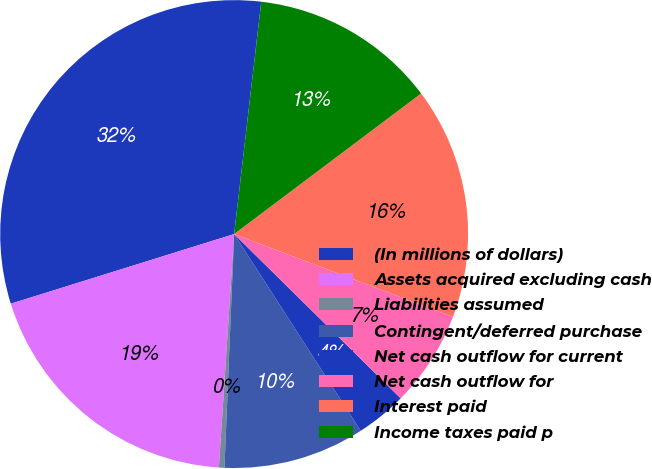<chart> <loc_0><loc_0><loc_500><loc_500><pie_chart><fcel>(In millions of dollars)<fcel>Assets acquired excluding cash<fcel>Liabilities assumed<fcel>Contingent/deferred purchase<fcel>Net cash outflow for current<fcel>Net cash outflow for<fcel>Interest paid<fcel>Income taxes paid p<nl><fcel>31.66%<fcel>19.15%<fcel>0.38%<fcel>9.76%<fcel>3.51%<fcel>6.63%<fcel>16.02%<fcel>12.89%<nl></chart> 